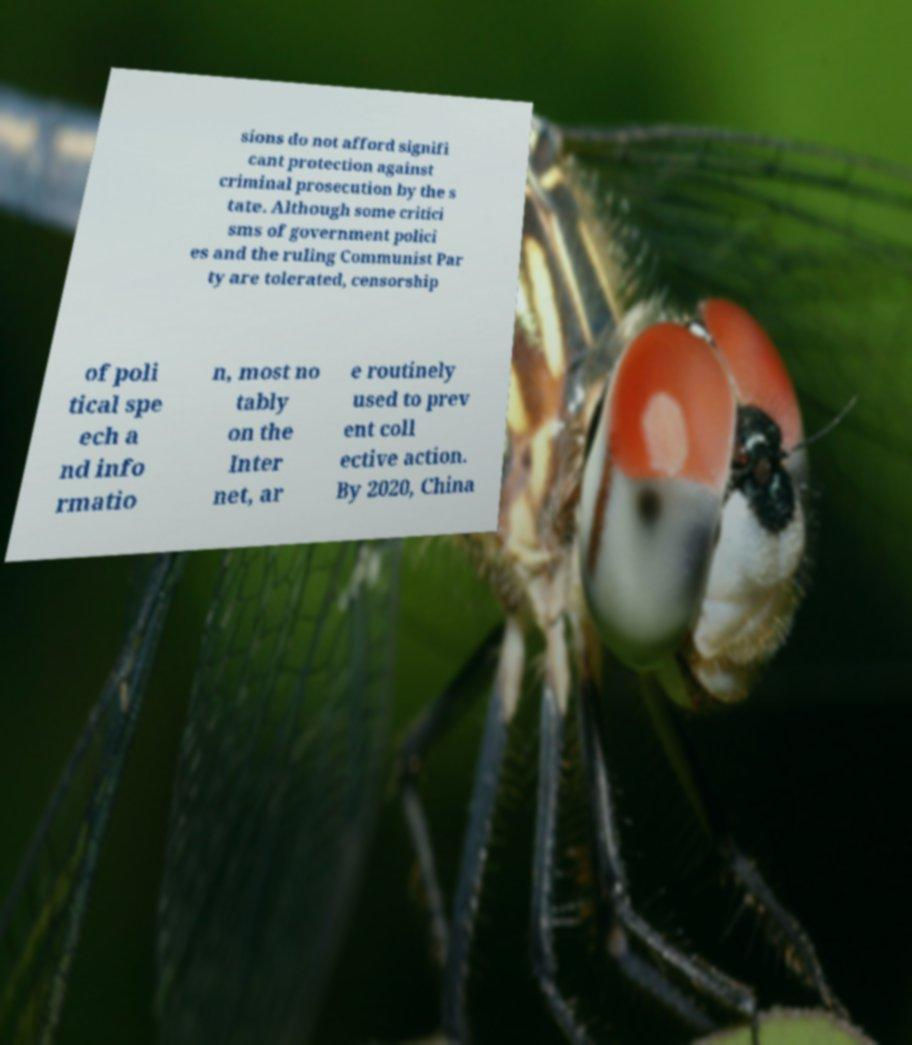Could you assist in decoding the text presented in this image and type it out clearly? sions do not afford signifi cant protection against criminal prosecution by the s tate. Although some critici sms of government polici es and the ruling Communist Par ty are tolerated, censorship of poli tical spe ech a nd info rmatio n, most no tably on the Inter net, ar e routinely used to prev ent coll ective action. By 2020, China 